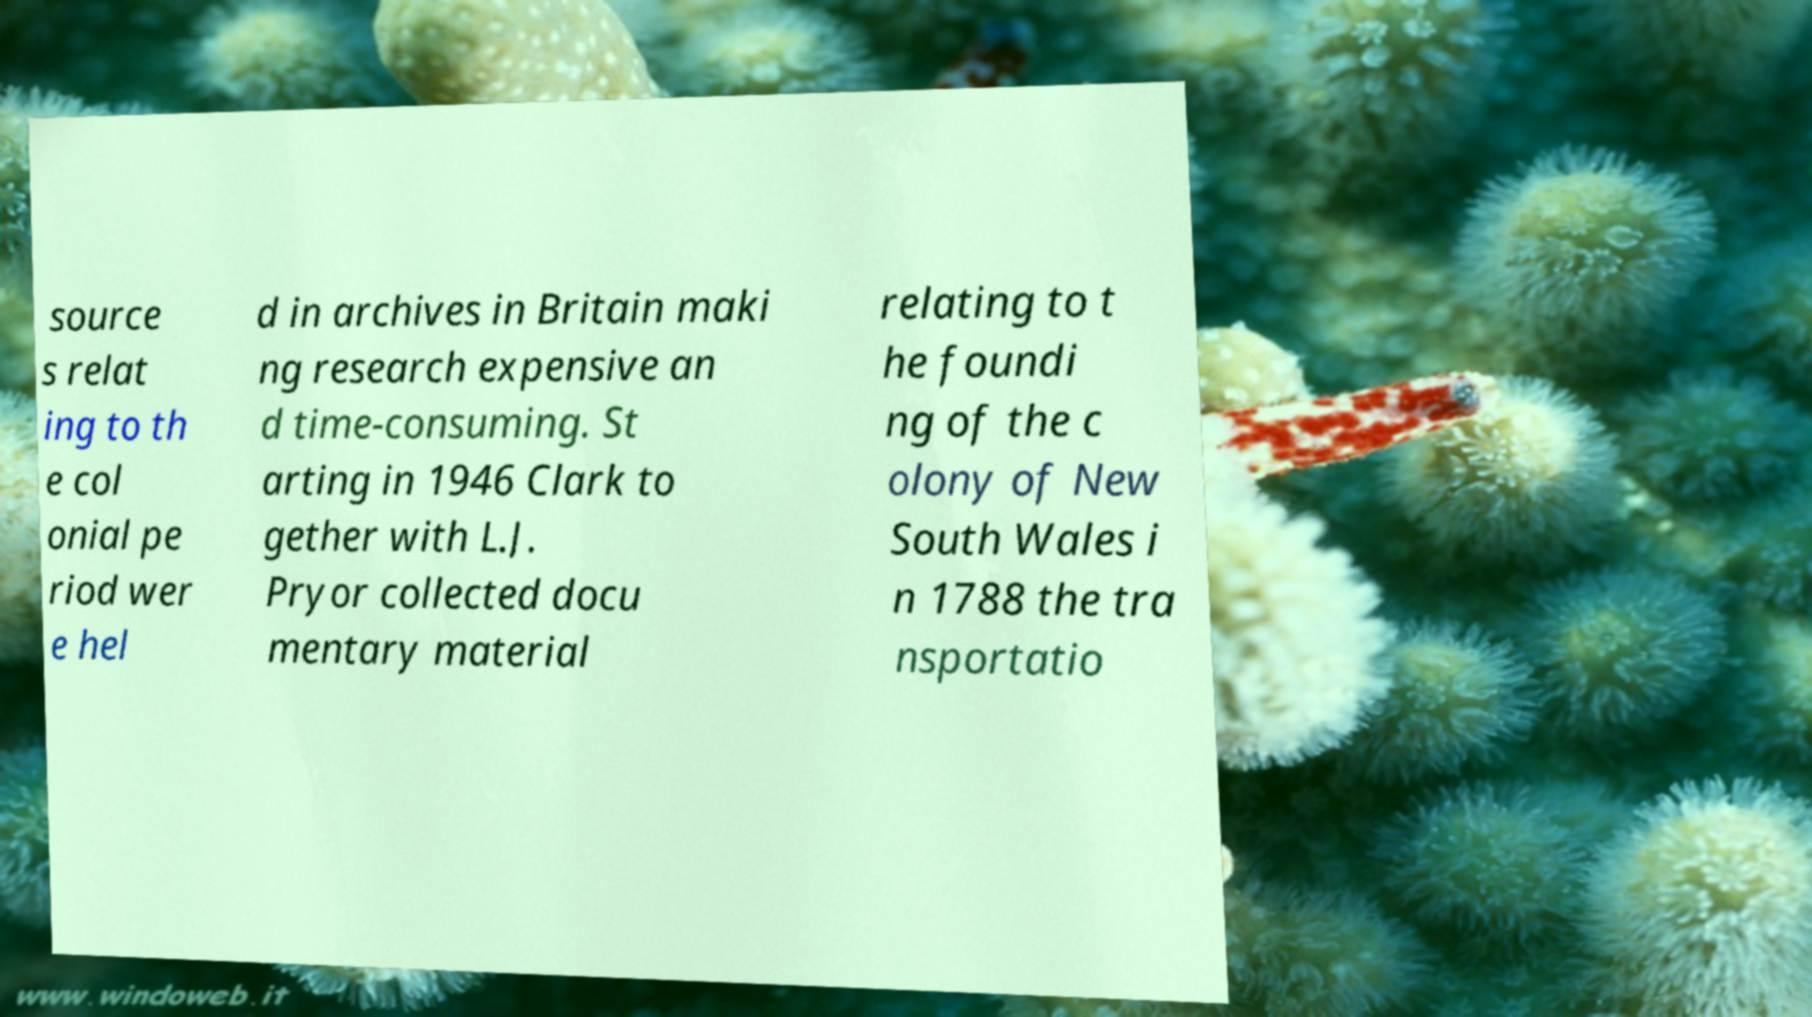I need the written content from this picture converted into text. Can you do that? source s relat ing to th e col onial pe riod wer e hel d in archives in Britain maki ng research expensive an d time-consuming. St arting in 1946 Clark to gether with L.J. Pryor collected docu mentary material relating to t he foundi ng of the c olony of New South Wales i n 1788 the tra nsportatio 